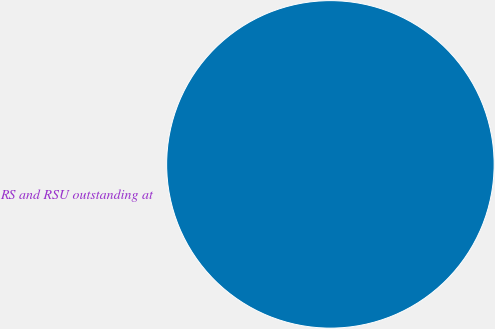Convert chart. <chart><loc_0><loc_0><loc_500><loc_500><pie_chart><fcel>RS and RSU outstanding at<nl><fcel>100.0%<nl></chart> 